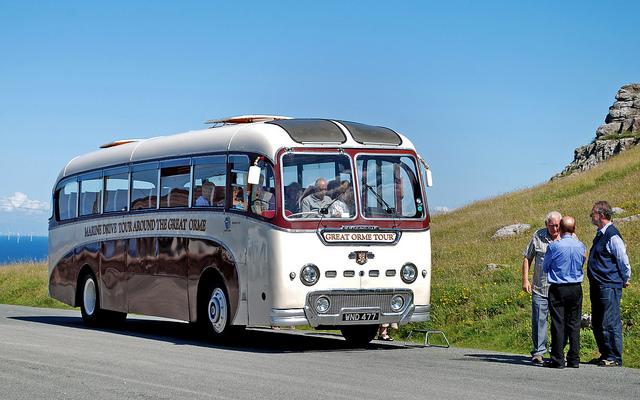How many people are outside of the vehicle?
Give a very brief answer. 3. Is this a new looking bus?
Quick response, please. No. What kind of vehicle is this?
Answer briefly. Bus. 